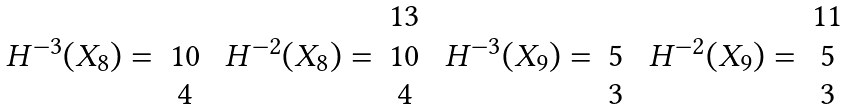<formula> <loc_0><loc_0><loc_500><loc_500>\begin{array} { c c } & \\ H ^ { - 3 } ( X _ { 8 } ) = & 1 0 \\ & 4 \\ \end{array} \ \begin{array} { c c } & 1 3 \\ H ^ { - 2 } ( X _ { 8 } ) = & 1 0 \\ & 4 \\ \end{array} \ \begin{array} { c c } & \\ H ^ { - 3 } ( X _ { 9 } ) = & 5 \\ & 3 \\ \end{array} \ \begin{array} { c c } & 1 1 \\ H ^ { - 2 } ( X _ { 9 } ) = & 5 \\ & 3 \\ \end{array}</formula> 